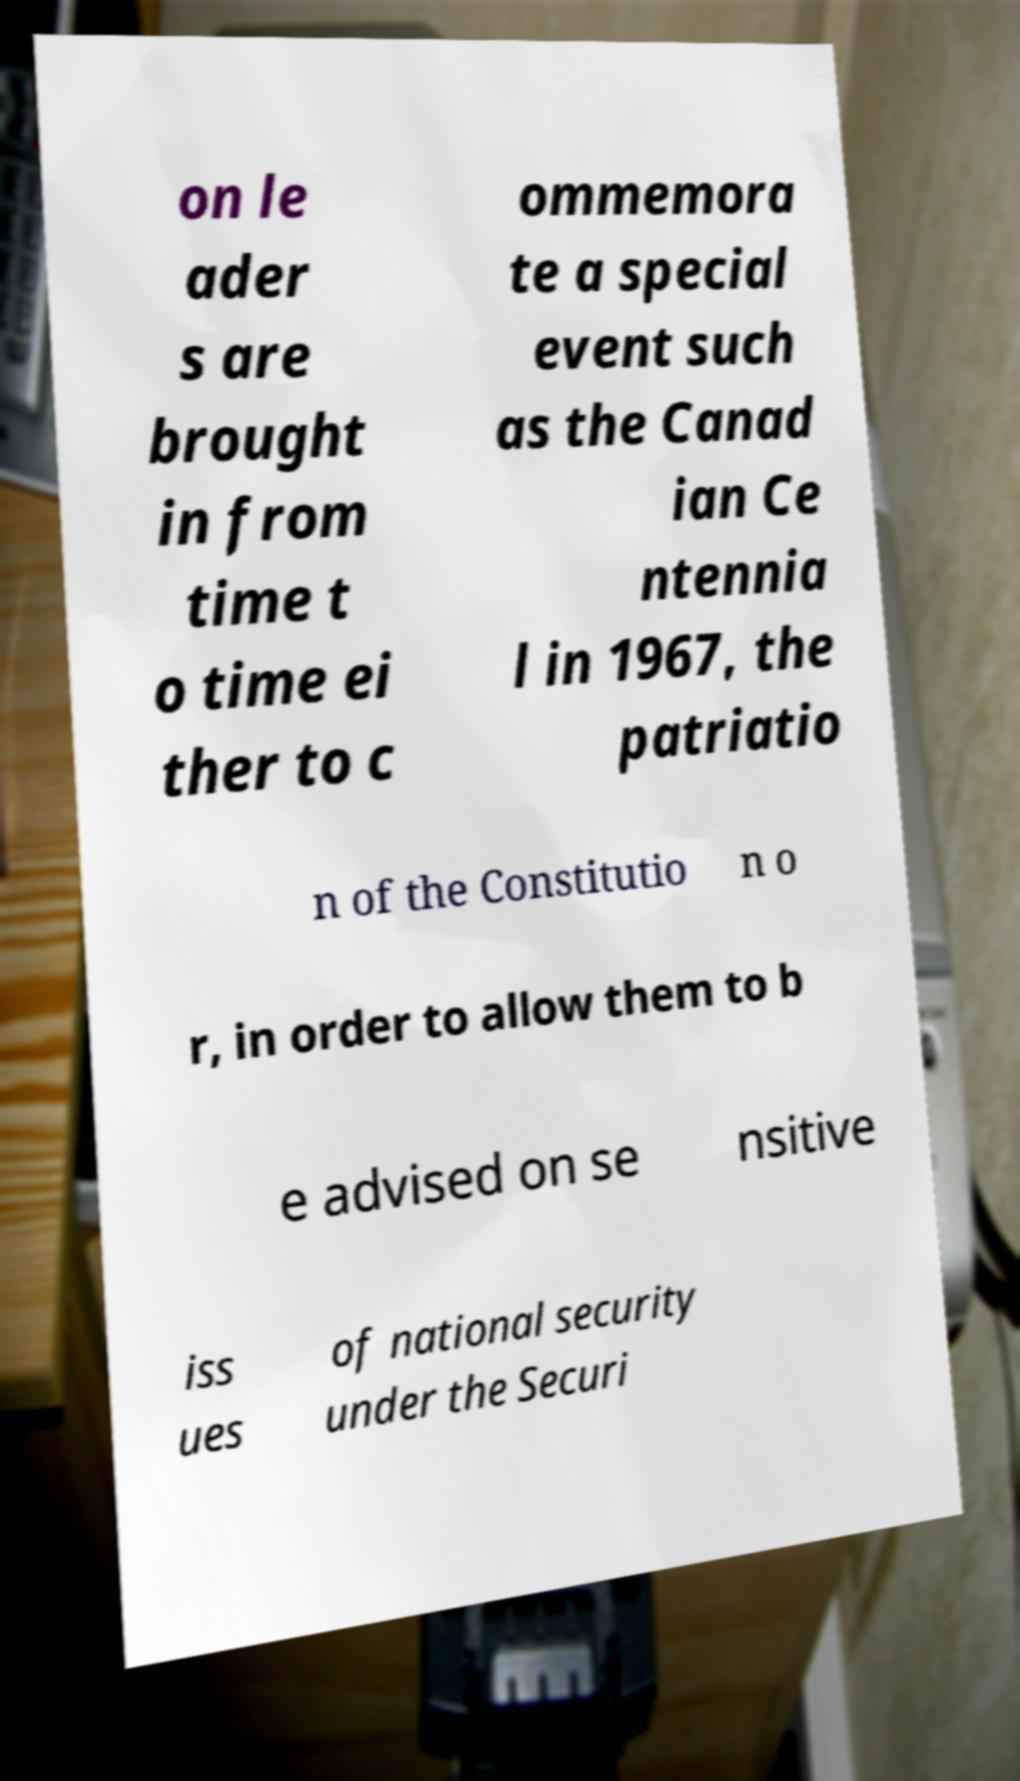I need the written content from this picture converted into text. Can you do that? on le ader s are brought in from time t o time ei ther to c ommemora te a special event such as the Canad ian Ce ntennia l in 1967, the patriatio n of the Constitutio n o r, in order to allow them to b e advised on se nsitive iss ues of national security under the Securi 